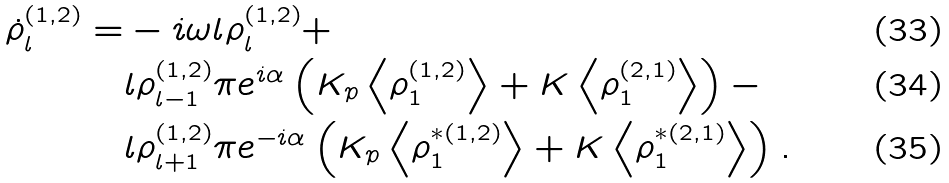Convert formula to latex. <formula><loc_0><loc_0><loc_500><loc_500>\dot { \rho } ^ { ( 1 , 2 ) } _ { l } = & - i \omega l \rho ^ { ( 1 , 2 ) } _ { l } + \\ & l \rho ^ { ( 1 , 2 ) } _ { l - 1 } \pi e ^ { i \alpha } \left ( K _ { p } \left < \rho ^ { ( 1 , 2 ) } _ { 1 } \right > + K \left < \rho ^ { ( 2 , 1 ) } _ { 1 } \right > \right ) - \\ & l \rho ^ { ( 1 , 2 ) } _ { l + 1 } \pi e ^ { - i \alpha } \left ( K _ { p } \left < \rho ^ { * ( 1 , 2 ) } _ { 1 } \right > + K \left < \rho ^ { * ( 2 , 1 ) } _ { 1 } \right > \right ) .</formula> 